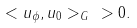Convert formula to latex. <formula><loc_0><loc_0><loc_500><loc_500>< u _ { \phi } , u _ { 0 } > _ { G } \ > 0 .</formula> 